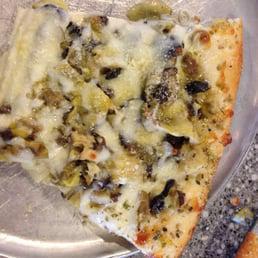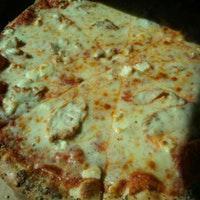The first image is the image on the left, the second image is the image on the right. For the images shown, is this caption "The left and right image contains the same number of full pizzas." true? Answer yes or no. No. The first image is the image on the left, the second image is the image on the right. Assess this claim about the two images: "The left image shows a rectangular metal tray containing something that is mostly yellow.". Correct or not? Answer yes or no. No. 